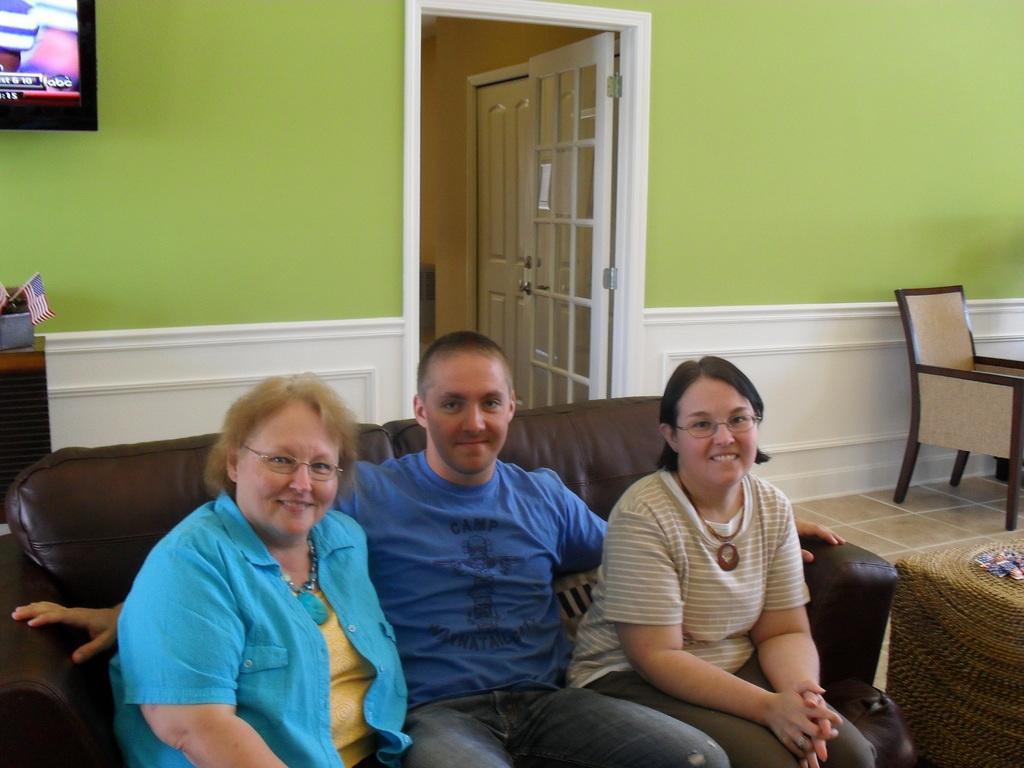In one or two sentences, can you explain what this image depicts? At the bottom three persons are sitting on the sofa. The background walls are green and white in color. In the middle a door is visible. In the left top a monitor is visible. In the middle left a table is visible on which flag and box is there. On the right middle a chair is visible. This image is taken inside a room during day time. 